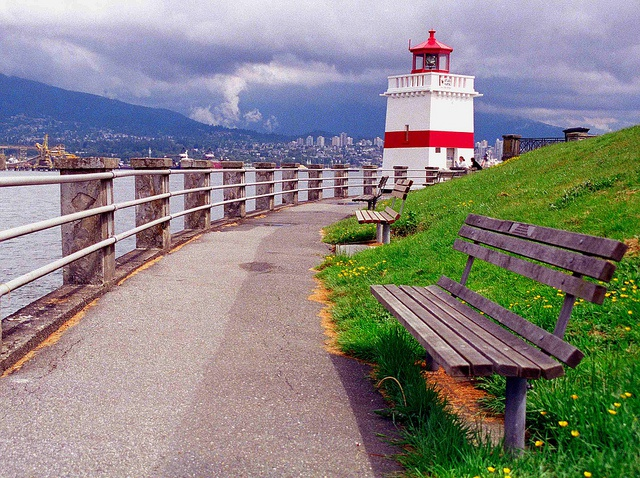Describe the objects in this image and their specific colors. I can see bench in white, purple, black, darkgray, and gray tones, bench in white, darkgray, black, maroon, and olive tones, bench in white, black, darkgray, brown, and pink tones, bench in white, maroon, black, darkgray, and brown tones, and people in white, lightgray, lightpink, brown, and maroon tones in this image. 